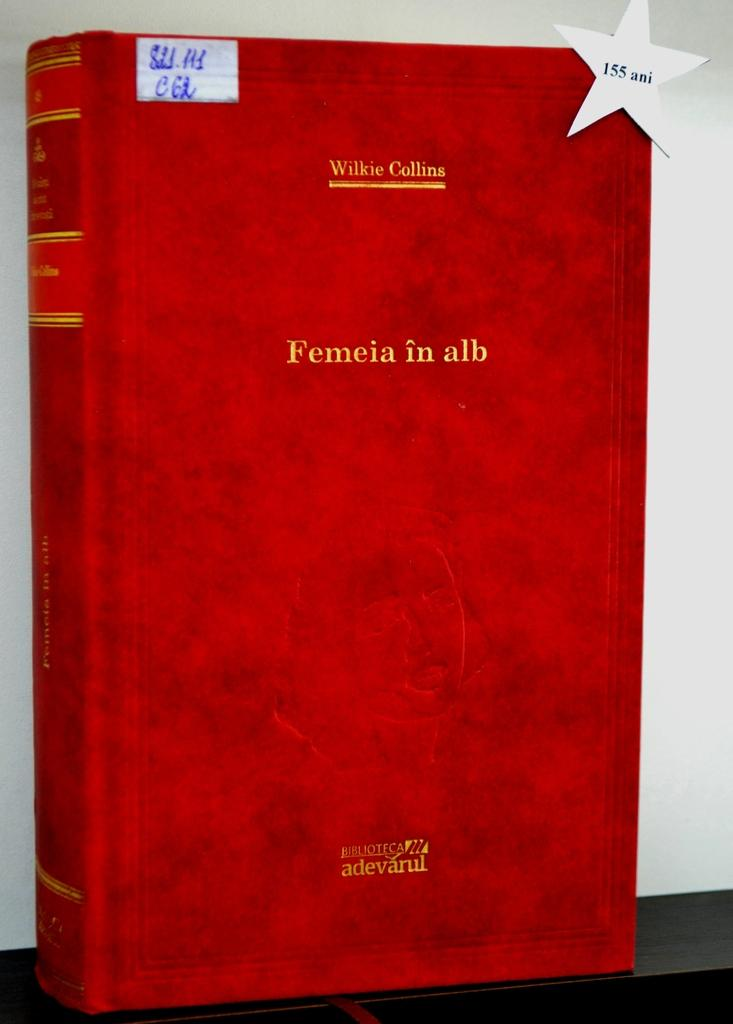<image>
Render a clear and concise summary of the photo. A red covered book has a title of, "Femeia in alb." 